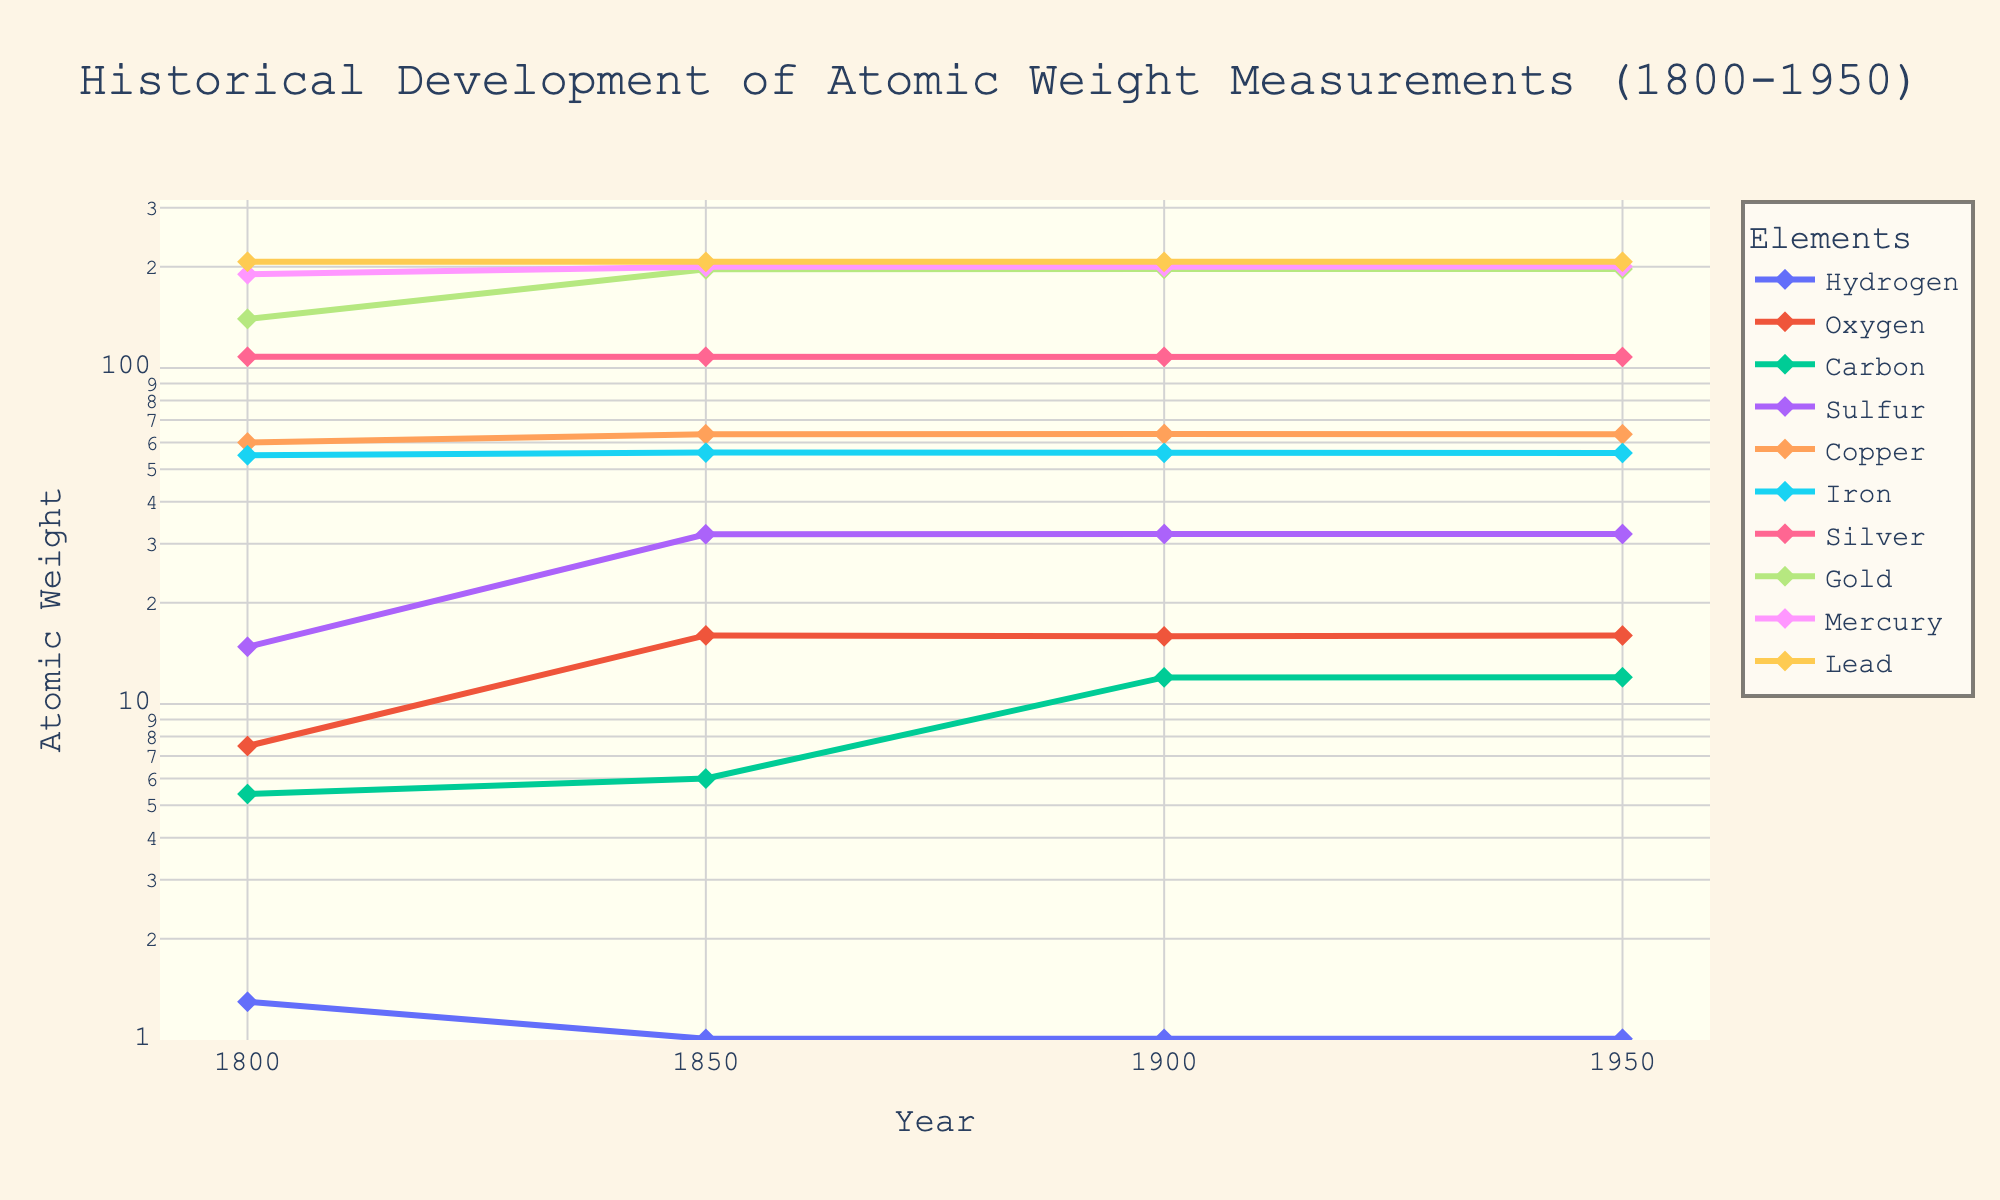What's the trend in the atomic weight of Hydrogen from 1800 to 1950? Observe the line for Hydrogen. The atomic weight decreases significantly from 1.3 in 1800 to 1.008 in 1850, and remains constant at 1.008 from 1850 to 1950
Answer: It stabilizes at 1.008 around 1850 Which element shows the most significant change in atomic weight between 1800 and 1900? Compare the changes in atomic weights for all elements between 1800 and 1900. Gold has the largest change, going from 140.0 to 197.2
Answer: Gold How does the atomic weight of Oxygen change over time? The atomic weight of Oxygen increases from 7.5 in 1800 to 16.0 in 1850, slightly fluctuates to 15.9 in 1900, and returns to 16.0 in 1950
Answer: Increasing then stabilizing Which element's atomic weight does not change across all years? Identify the elements whose lines are horizontal for all years. Silver maintains a constant atomic weight of around 108.0 throughout
Answer: Silver Between 1850 and 1950, which element shows a decreasing trend in atomic weight? Examine the elements' lines for a downward slope between 1850 and 1950. Lead's atomic weight decreases from 207.0 to 206.9, then to 207.2
Answer: Lead How much does the atomic weight of Carbon increase from 1800 to 1950? Carbon's atomic weight changes from 5.4 in 1800 to 12.01 in 1950. Calculate the difference: 12.01 - 5.4 = 6.61
Answer: 6.61 During which period does Iron’s atomic weight remain unchanged? Look at the time intervals for Iron’s line. It remains unchanged at 56.0 from 1850 to 1900
Answer: 1850 to 1900 Compare the atomic weights of Mercury and Lead in 1900. Which one is heavier? Refer to the values in 1900 for Mercury (200.0) and Lead (206.9). Lead has a higher atomic weight
Answer: Lead Identify the element that has an atomic weight of roughly 200 in 1950. Check the values of all elements for 1950. Mercury has an atomic weight of 200.59
Answer: Mercury What's the average atomic weight of Copper from 1800 to 1950? Sum the atomic weights of Copper (60, 63.5, 63.6, 63.54) and divide by 4. (60 + 63.5 + 63.6 + 63.54) / 4 = 62.66
Answer: 62.66 